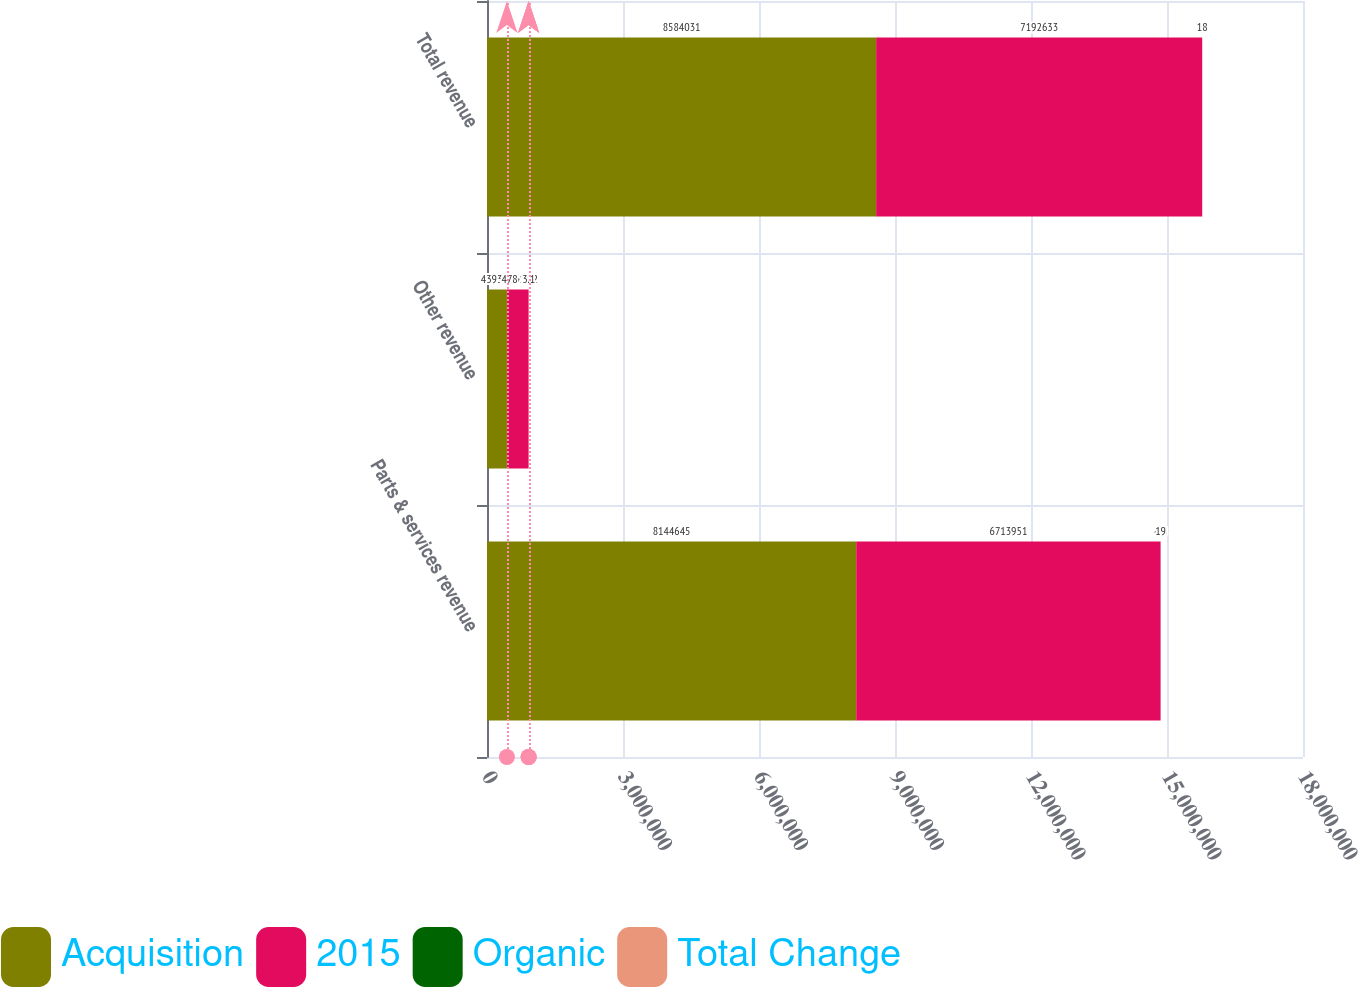Convert chart. <chart><loc_0><loc_0><loc_500><loc_500><stacked_bar_chart><ecel><fcel>Parts & services revenue<fcel>Other revenue<fcel>Total revenue<nl><fcel>Acquisition<fcel>8.14464e+06<fcel>439386<fcel>8.58403e+06<nl><fcel>2015<fcel>6.71395e+06<fcel>478682<fcel>7.19263e+06<nl><fcel>Organic<fcel>4.8<fcel>11.2<fcel>3.7<nl><fcel>Total Change<fcel>19<fcel>3.1<fcel>18<nl></chart> 